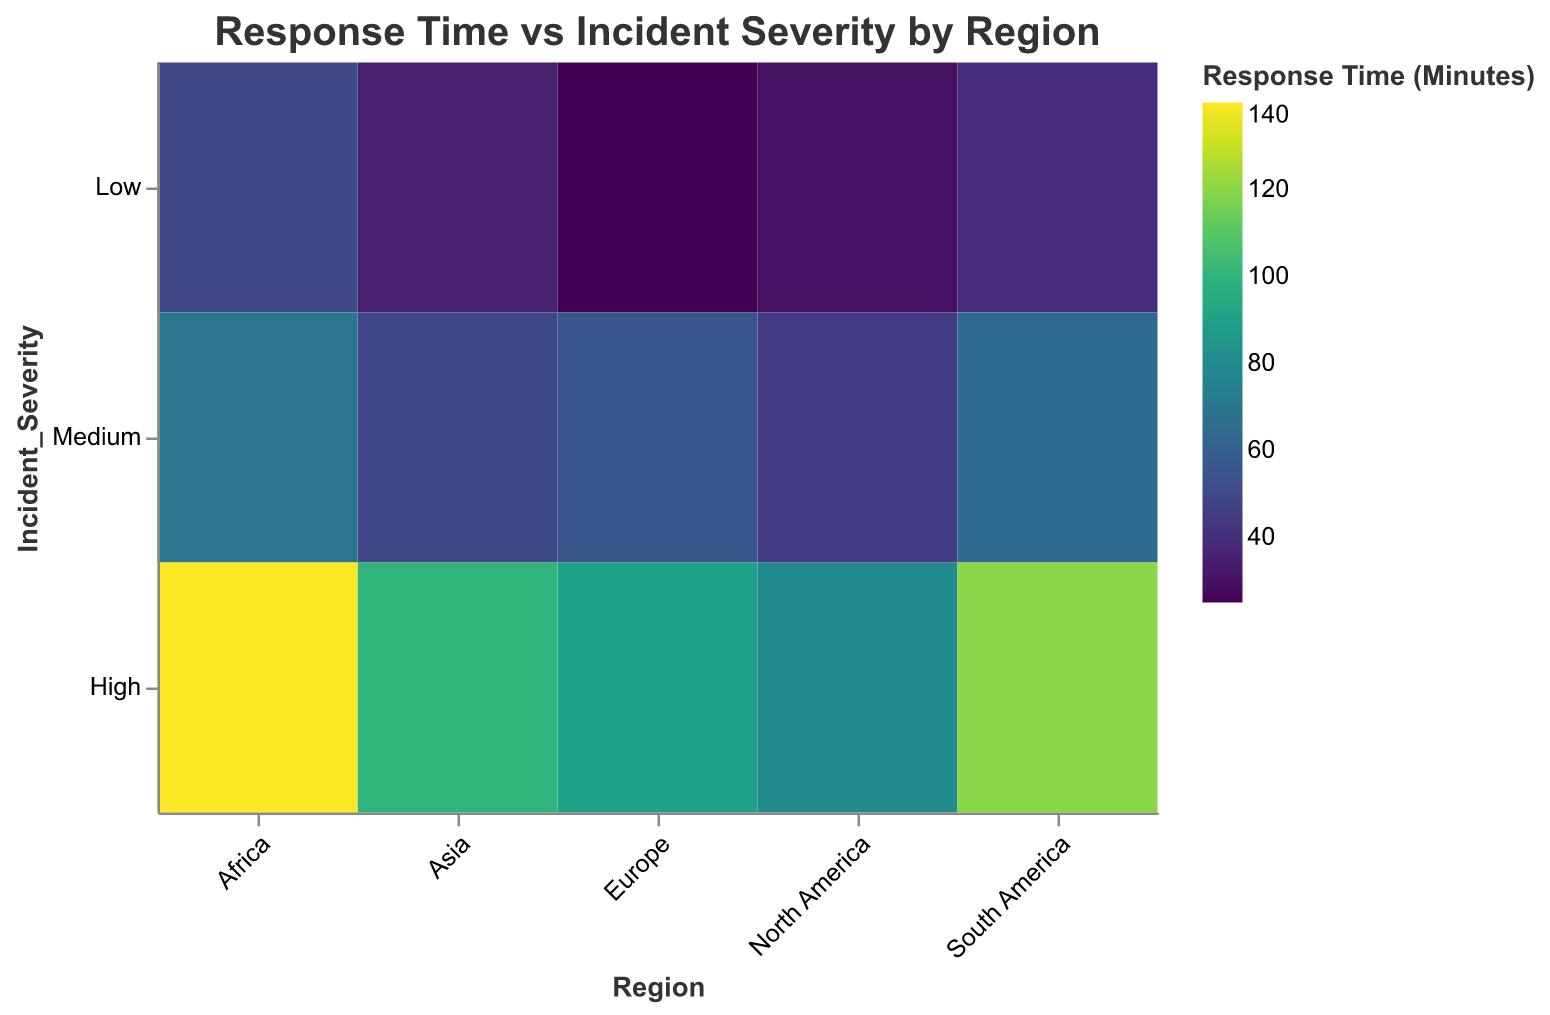What is the title of the heatmap? The title is typically located at the top of the figure. It summarizes the main focus of the plot. Here, the title is clearly indicated.
Answer: Response Time vs Incident Severity by Region Which region has the fastest response time for high severity incidents? Identify the region with the lowest color value (indicating the shortest response time) under the "High" severity category, located in the top category on the vertical axis.
Answer: North America What is the response time for medium severity incidents in Asia? Locate the cell at the intersection of "Asia" on the x-axis and "Medium" on the y-axis. The color here corresponds to the response time.
Answer: 50 minutes How many data points are there in the heatmap? To know the total number of data points, count each unique combination of regions and severity levels represented by colored cells in the heatmap. There are five regions and three severity levels.
Answer: 15 Which region has the longest response time for low severity incidents? Check the row labeled "Low" and identify the cell with the highest color value (representing the longest response time).
Answer: Africa What is the average response time for high severity incidents across all regions? Add the response times for high severity incidents in each region (80 + 90 + 100 + 120 + 140) and then divide by the number of regions (5).
Answer: 106 minutes Compare the response times for medium severity incidents in Europe and South America. Which one is faster? Review the colors for "Medium" incidents in the Europe and South America columns, then compare their numerical response times.
Answer: Europe What trend do you observe in response times as incident severity increases in North America? Move from top to bottom within the North America column, noting the color progression and corresponding response times for low, medium, and high severity levels.
Answer: Response times increase with incident severity Which region shows the highest overall response times across all severity levels? Summarize the colors for all severity levels within each region and find the one with the highest intensity colors, indicating longer response times overall.
Answer: Africa Are there any regions where the response time for medium severity incidents is higher than for high severity incidents? Compare the color values for "Medium" and "High" within each region to see if any region contradicts the natural progression of increasing severity leading to longer response times.
Answer: No 